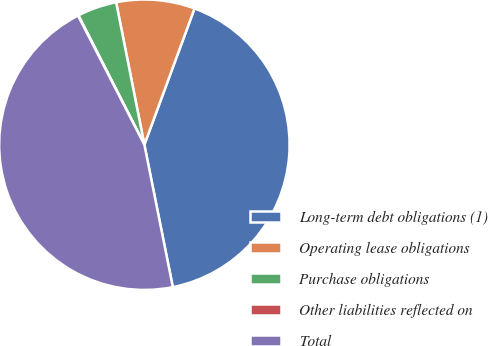<chart> <loc_0><loc_0><loc_500><loc_500><pie_chart><fcel>Long-term debt obligations (1)<fcel>Operating lease obligations<fcel>Purchase obligations<fcel>Other liabilities reflected on<fcel>Total<nl><fcel>41.24%<fcel>8.73%<fcel>4.39%<fcel>0.05%<fcel>45.58%<nl></chart> 